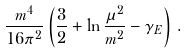Convert formula to latex. <formula><loc_0><loc_0><loc_500><loc_500>\frac { m ^ { 4 } } { 1 6 \pi ^ { 2 } } \left ( \frac { 3 } { 2 } + \ln \frac { \mu ^ { 2 } } { m ^ { 2 } } - \gamma _ { E } \right ) \, .</formula> 